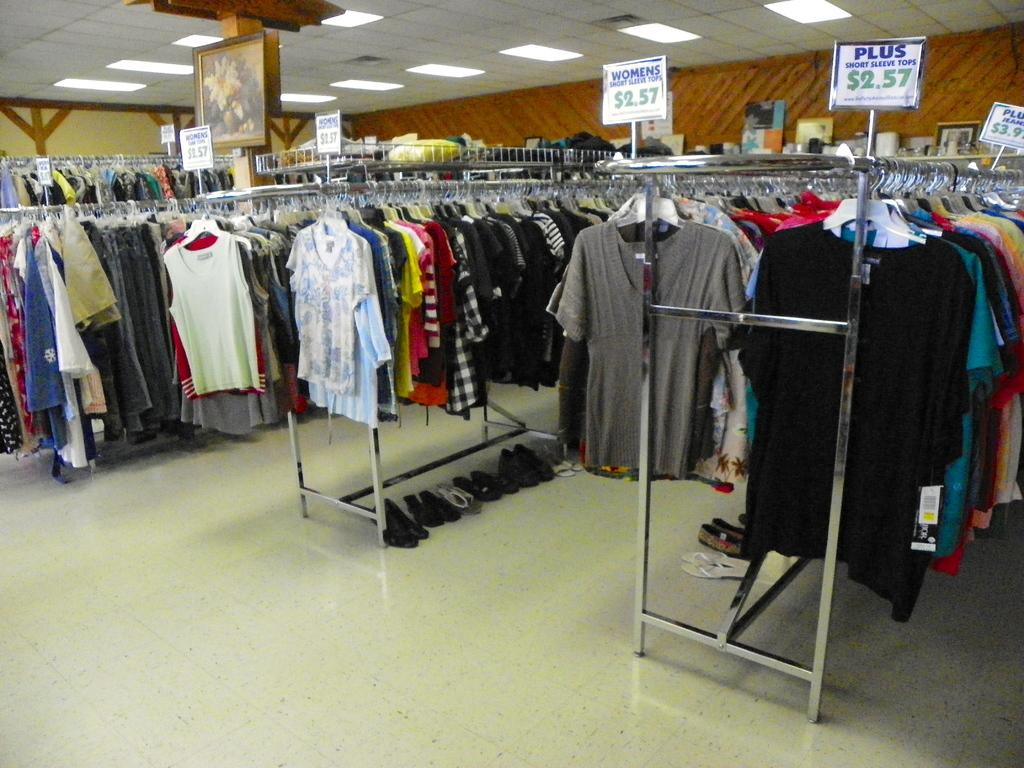<image>
Summarize the visual content of the image. A sign above a rack of clothes is titled plus. 